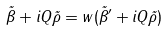<formula> <loc_0><loc_0><loc_500><loc_500>\vec { \beta } + i Q \vec { \rho } = w ( \vec { \beta } ^ { \prime } + i Q \vec { \rho } )</formula> 